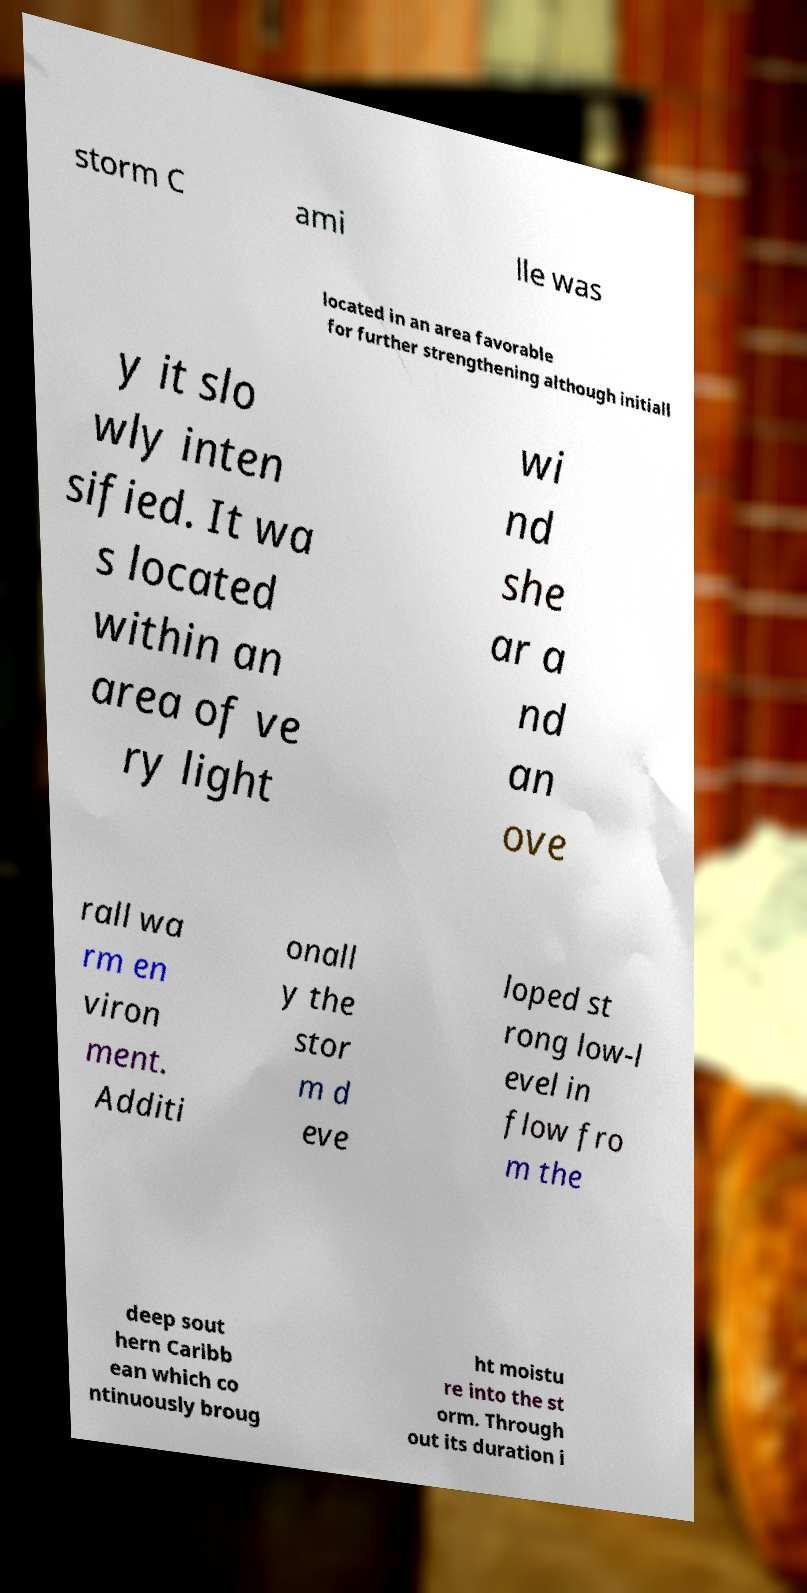What messages or text are displayed in this image? I need them in a readable, typed format. storm C ami lle was located in an area favorable for further strengthening although initiall y it slo wly inten sified. It wa s located within an area of ve ry light wi nd she ar a nd an ove rall wa rm en viron ment. Additi onall y the stor m d eve loped st rong low-l evel in flow fro m the deep sout hern Caribb ean which co ntinuously broug ht moistu re into the st orm. Through out its duration i 